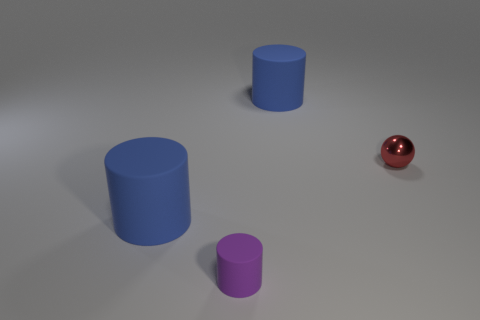Is there anything else that is the same size as the red metallic object?
Your answer should be compact. Yes. How many red spheres are left of the red metallic thing?
Provide a succinct answer. 0. Are the purple object and the red thing made of the same material?
Keep it short and to the point. No. How many rubber cylinders are both behind the purple object and in front of the small red metal sphere?
Provide a short and direct response. 1. How many other objects are there of the same color as the small matte cylinder?
Provide a succinct answer. 0. How many green things are matte objects or big cylinders?
Your answer should be very brief. 0. What is the size of the ball?
Provide a succinct answer. Small. How many metal objects are either balls or small objects?
Your response must be concise. 1. Are there fewer red balls than tiny cyan cubes?
Offer a terse response. No. How many other objects are there of the same material as the tiny red object?
Ensure brevity in your answer.  0. 